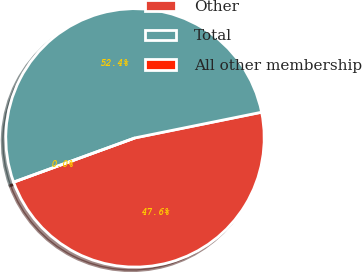Convert chart to OTSL. <chart><loc_0><loc_0><loc_500><loc_500><pie_chart><fcel>Other<fcel>Total<fcel>All other membership<nl><fcel>47.62%<fcel>52.38%<fcel>0.0%<nl></chart> 